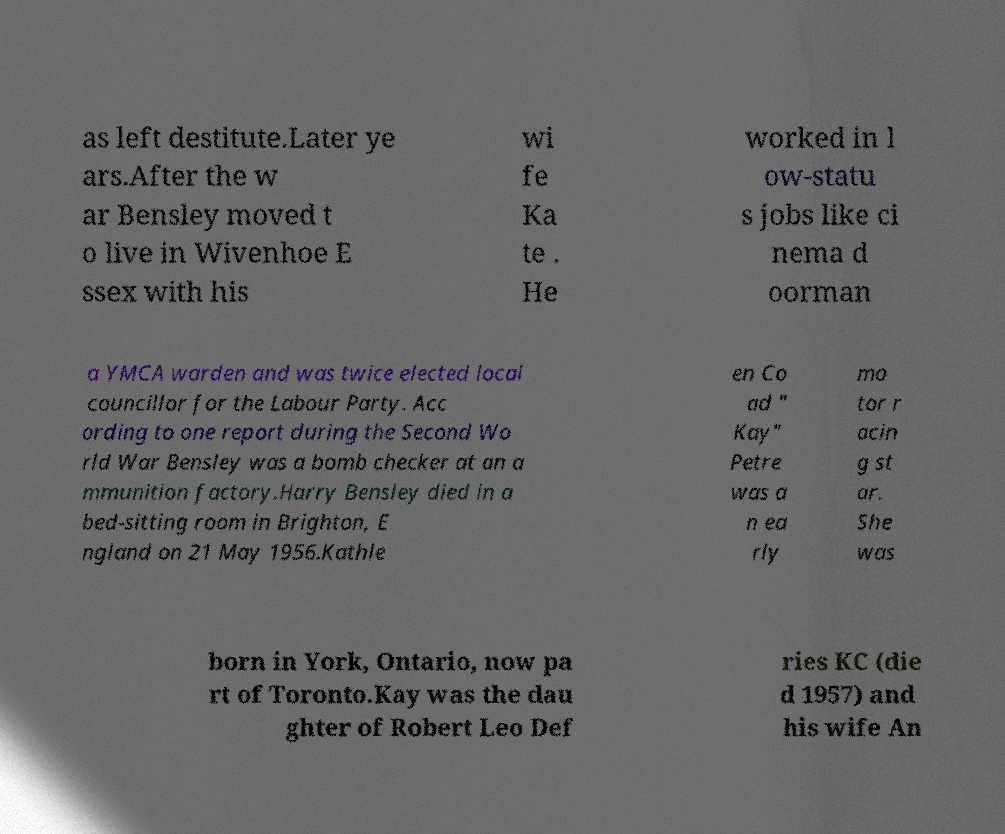Could you assist in decoding the text presented in this image and type it out clearly? as left destitute.Later ye ars.After the w ar Bensley moved t o live in Wivenhoe E ssex with his wi fe Ka te . He worked in l ow-statu s jobs like ci nema d oorman a YMCA warden and was twice elected local councillor for the Labour Party. Acc ording to one report during the Second Wo rld War Bensley was a bomb checker at an a mmunition factory.Harry Bensley died in a bed-sitting room in Brighton, E ngland on 21 May 1956.Kathle en Co ad " Kay" Petre was a n ea rly mo tor r acin g st ar. She was born in York, Ontario, now pa rt of Toronto.Kay was the dau ghter of Robert Leo Def ries KC (die d 1957) and his wife An 